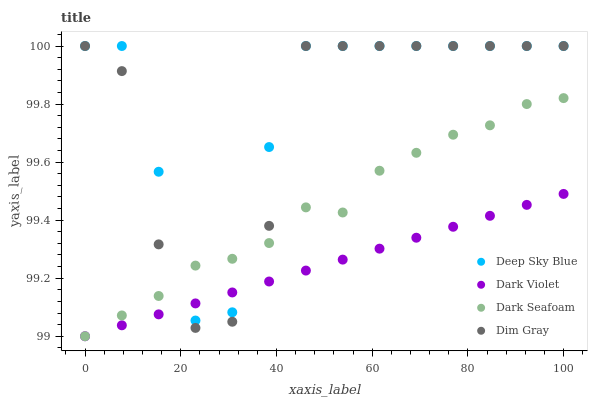Does Dark Violet have the minimum area under the curve?
Answer yes or no. Yes. Does Deep Sky Blue have the maximum area under the curve?
Answer yes or no. Yes. Does Dim Gray have the minimum area under the curve?
Answer yes or no. No. Does Dim Gray have the maximum area under the curve?
Answer yes or no. No. Is Dark Violet the smoothest?
Answer yes or no. Yes. Is Dim Gray the roughest?
Answer yes or no. Yes. Is Dim Gray the smoothest?
Answer yes or no. No. Is Dark Violet the roughest?
Answer yes or no. No. Does Dark Seafoam have the lowest value?
Answer yes or no. Yes. Does Dim Gray have the lowest value?
Answer yes or no. No. Does Deep Sky Blue have the highest value?
Answer yes or no. Yes. Does Dark Violet have the highest value?
Answer yes or no. No. Does Deep Sky Blue intersect Dark Violet?
Answer yes or no. Yes. Is Deep Sky Blue less than Dark Violet?
Answer yes or no. No. Is Deep Sky Blue greater than Dark Violet?
Answer yes or no. No. 